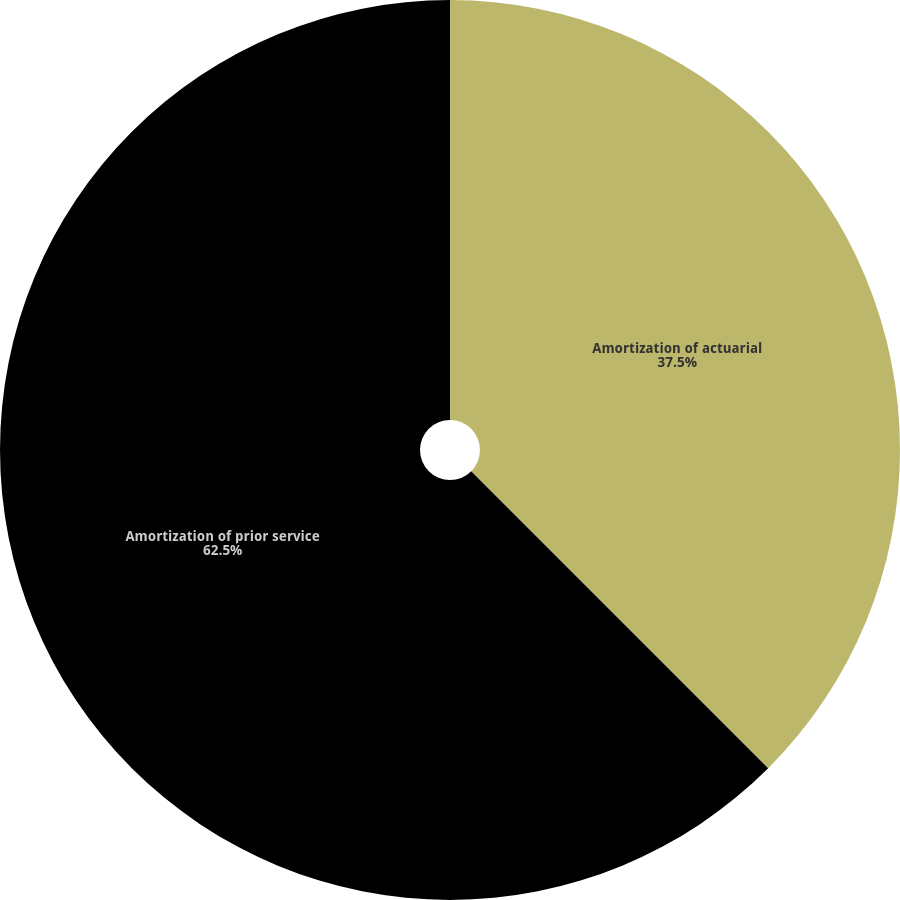Convert chart. <chart><loc_0><loc_0><loc_500><loc_500><pie_chart><fcel>Amortization of actuarial<fcel>Amortization of prior service<nl><fcel>37.5%<fcel>62.5%<nl></chart> 